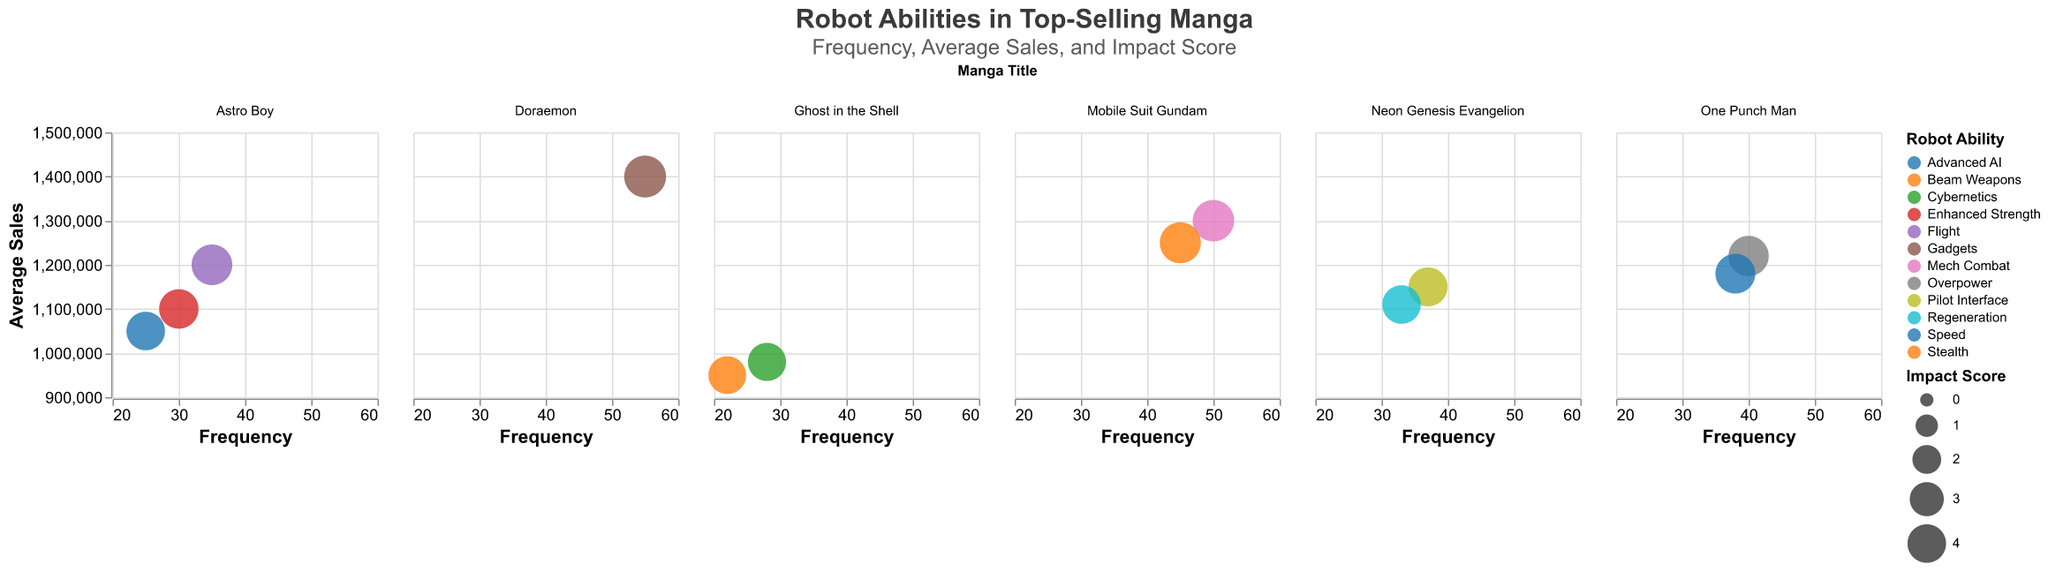What is the frequency range of the robot abilities for the manga "Astro Boy"? The x-axis shows the frequency of robot abilities. For "Astro Boy," the abilities "Flight," "Enhanced Strength," and "Advanced AI" have frequencies of 35, 30, and 25, respectively.
Answer: 25-35 Which manga features the robot ability with the highest impact score, and what is that ability? Inspecting the size of the circles in the plots reveals that "Doraemon" has the largest circle, indicating that "Gadgets" has the highest impact score of 4.8.
Answer: Doraemon, Gadgets How does the frequency of "Pilot Interface" in "Neon Genesis Evangelion" compare to the frequency of "Overpower" in "One Punch Man"? "Pilot Interface" in "Neon Genesis Evangelion" has a frequency of 37, while "Overpower" in "One Punch Man" has a frequency of 40. Comparing these, 37 is less than 40.
Answer: Less What is the average sales figure for robot abilities in "Mobile Suit Gundam"? The y-axis shows the average sales figures. "Mech Combat" and "Beam Weapons" in "Mobile Suit Gundam" have average sales figures of 1,300,000 and 1,250,000 respectively. The average is (1,300,000 + 1,250,000) / 2 = 1,275,000.
Answer: 1,275,000 Which robot ability has the highest frequency across all manga, and what is its corresponding manga? Scanning through the subplots, "Gadgets" in "Doraemon" has the highest frequency of 55 as indicated on the x-axis.
Answer: Gadgets, Doraemon What are the impact scores for "Advanced AI" in "Astro Boy" and "Cybernetics" in "Ghost in the Shell"? Hovering over or examining the size of the circles reveals that "Advanced AI" in "Astro Boy" has an impact score of 4.0, while "Cybernetics" in "Ghost in the Shell" has an impact score of 3.9.
Answer: 4.0, 3.9 Compare the average sales of "Enhanced Strength" in "Astro Boy" and "Speed" in "One Punch Man". Which has a higher sales figure? Checking the y-axis, "Enhanced Strength" in "Astro Boy" has average sales of 1,100,000, whereas "Speed" in "One Punch Man" has average sales of 1,180,000. Thus, "Speed" in "One Punch Man" has a higher sales figure.
Answer: Speed (One Punch Man) What is the total frequency of robot abilities in "Neon Genesis Evangelion"? The frequencies are 37 for "Pilot Interface" and 33 for "Regeneration." Summing these up gives 37 + 33 = 70.
Answer: 70 Which robot ability in "Mobile Suit Gundam" has both a high frequency and the highest average sales? "Mech Combat" has a frequency of 50 and average sales of 1,300,000, while "Beam Weapons" has a lower frequency of 45 and average sales of 1,250,000. Thus, "Mech Combat" fits the criteria.
Answer: Mech Combat What is the relationship between the impact score and average sales for robot abilities in "One Punch Man"? Observing the sizes of the circles and their positions, "Overpower" has an impact score of 4.4 and average sales of 1,220,000, while "Speed" has an impact score of 4.3 and average sales of 1,180,000. Both abilities have high impact scores and high average sales, suggesting a positive relationship.
Answer: Positive relationship 